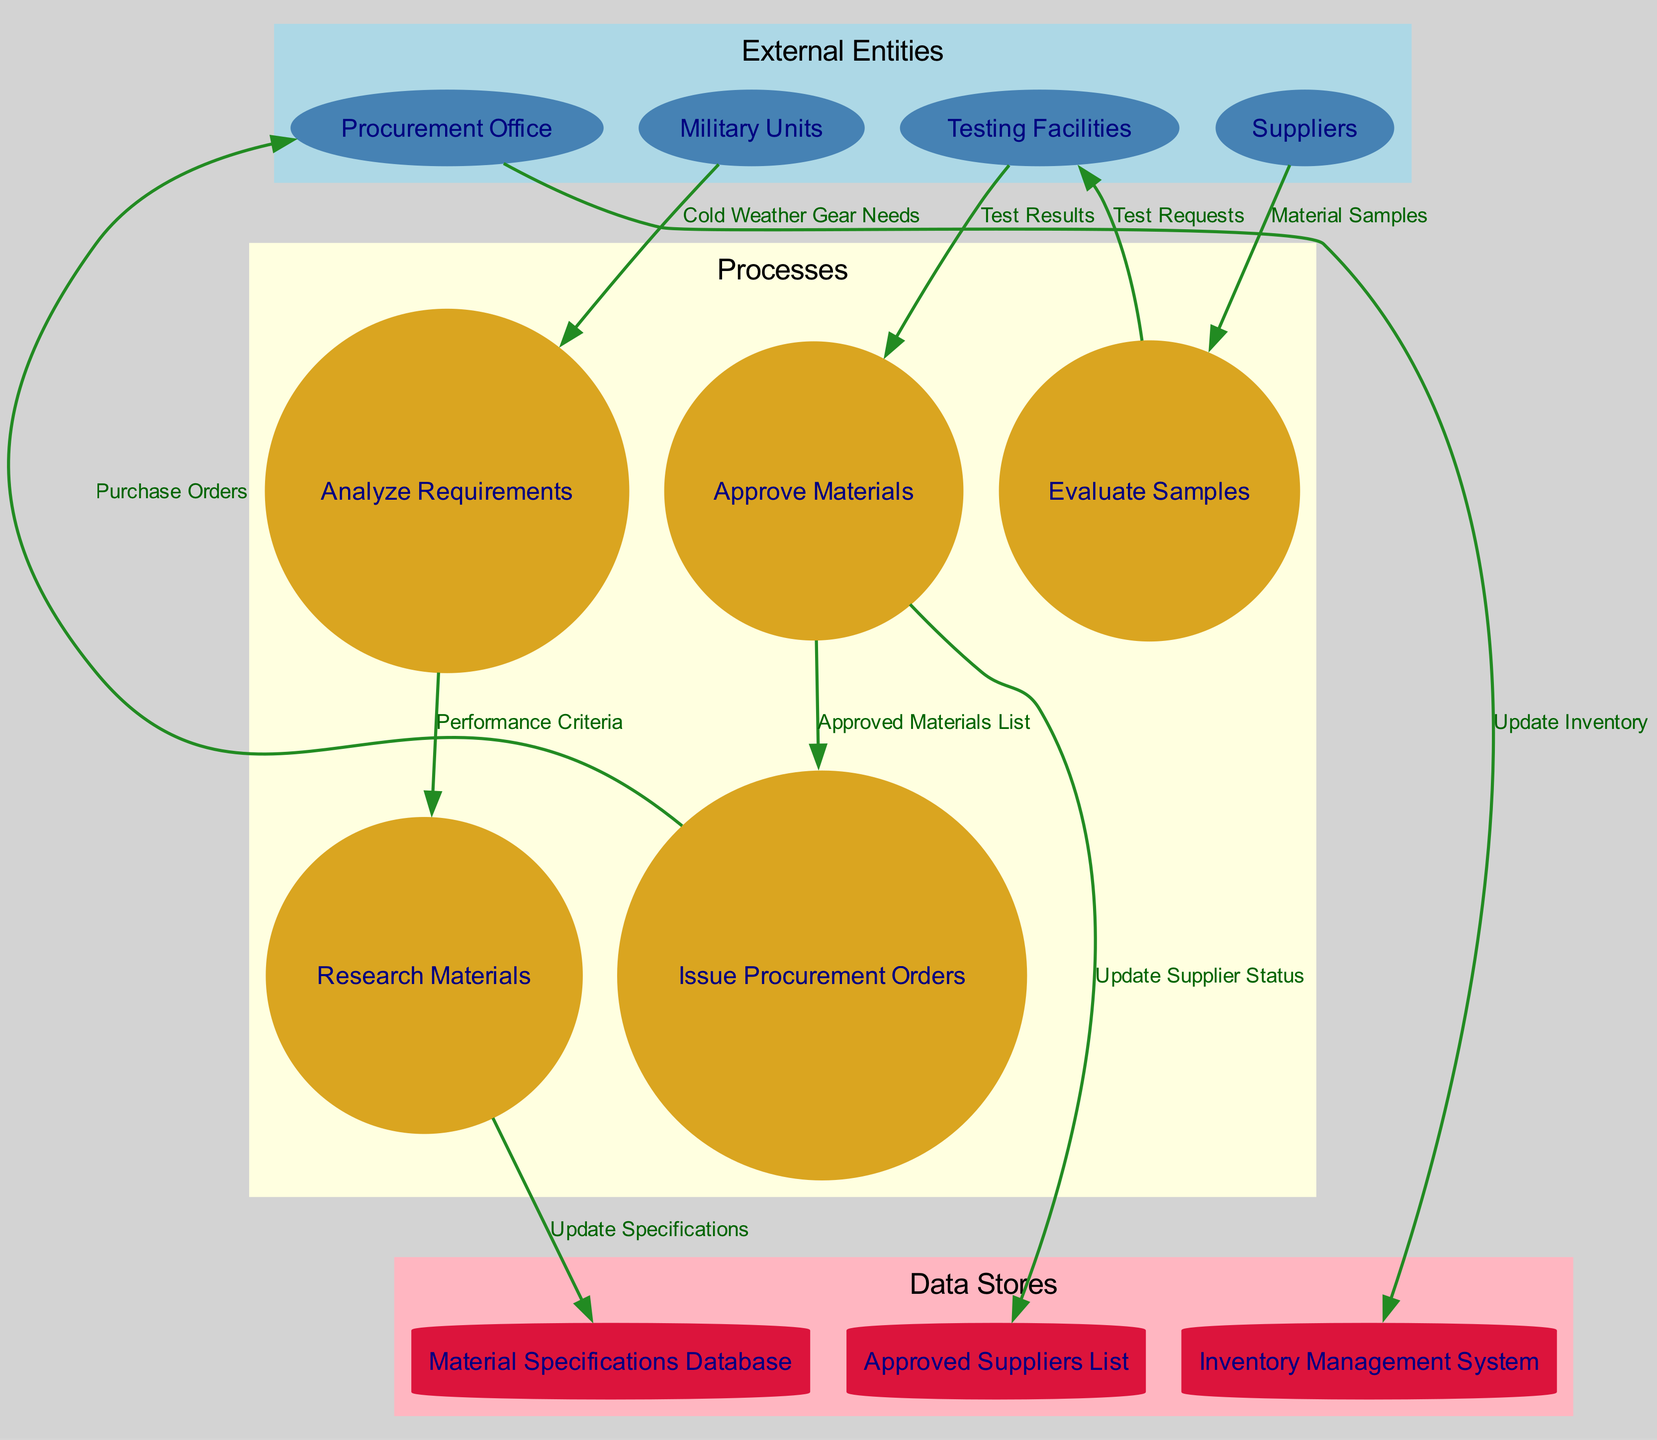What's the total number of external entities in the diagram? The diagram lists four items under external entities: Procurement Office, Testing Facilities, Suppliers, and Military Units. Therefore, the total is four.
Answer: 4 What data store is updated by the Procurement Office? The data flow from the Procurement Office leads to the Inventory Management System and indicates that the inventory is updated based on procurement actions.
Answer: Inventory Management System How many processes occur after reviewing the material samples? After reviewing the material samples, two processes occur: 'Approve Materials' and 'Issue Procurement Orders'. Thus, the total is two.
Answer: 2 Which entity provides material samples for evaluation? The flow from the Suppliers to the Evaluate Samples process indicates that suppliers are the source of material samples for evaluation.
Answer: Suppliers What data flow is labeled as 'Test Results'? The arrow from Testing Facilities to the Approve Materials process carries the label 'Test Results', indicating this is the data flow for the result of testing materials.
Answer: Test Results What is the next step after 'Analyze Requirements'? The direct flow from 'Analyze Requirements' to 'Research Materials' indicates that the next step in the process is researching materials after analyzing the requirements.
Answer: Research Materials Which data store receives an update when materials are approved? The data flow from the Approve Materials process to the Approved Suppliers List indicates that this list receives an update when materials are approved.
Answer: Approved Suppliers List What is the relationship between 'Evaluate Samples' and 'Test Requests'? The connection from Evaluate Samples to Testing Facilities is labeled 'Test Requests', signifying that Evaluate Samples generates requests for testing the materials.
Answer: Test Requests How many processes are there in total? The diagram includes five processes: Analyze Requirements, Research Materials, Evaluate Samples, Approve Materials, and Issue Procurement Orders, making the total count five.
Answer: 5 